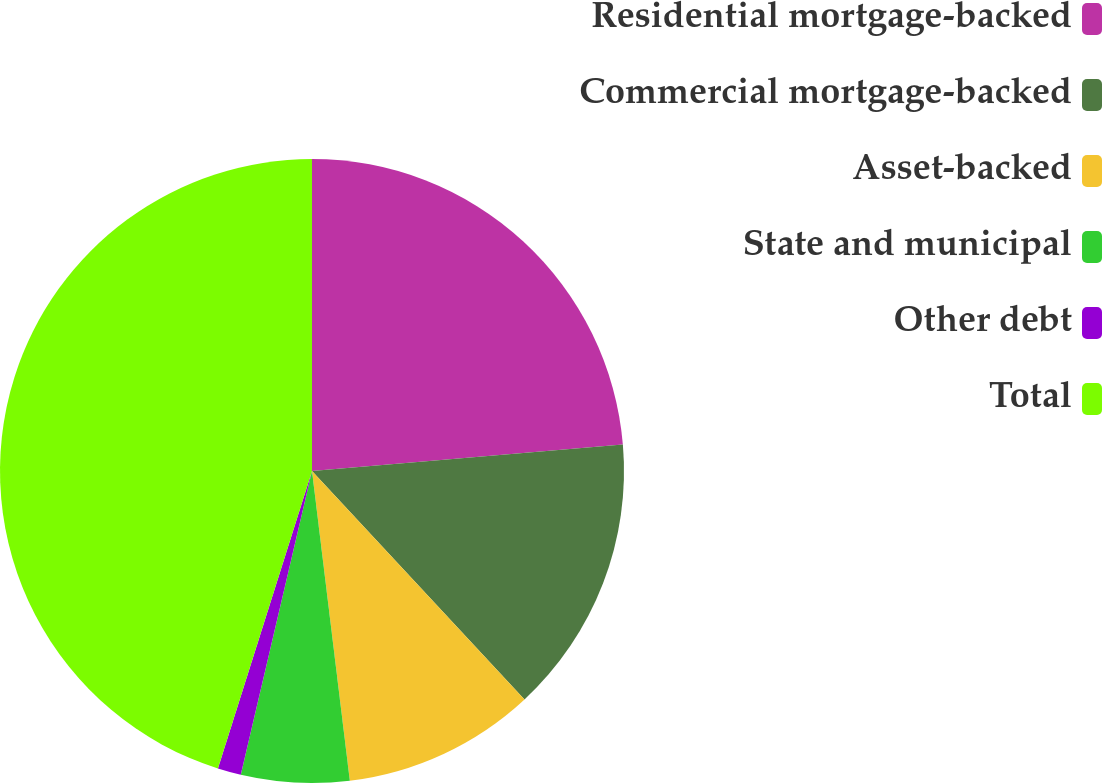<chart> <loc_0><loc_0><loc_500><loc_500><pie_chart><fcel>Residential mortgage-backed<fcel>Commercial mortgage-backed<fcel>Asset-backed<fcel>State and municipal<fcel>Other debt<fcel>Total<nl><fcel>23.65%<fcel>14.42%<fcel>9.99%<fcel>5.6%<fcel>1.21%<fcel>45.12%<nl></chart> 